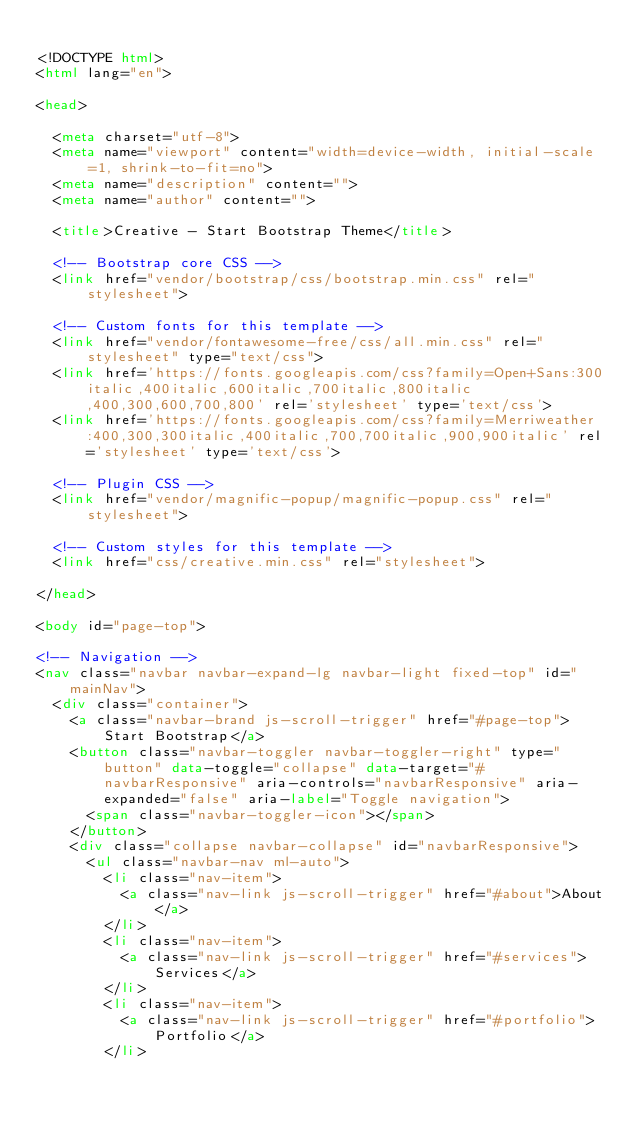<code> <loc_0><loc_0><loc_500><loc_500><_HTML_>
<!DOCTYPE html>
<html lang="en">

<head>

  <meta charset="utf-8">
  <meta name="viewport" content="width=device-width, initial-scale=1, shrink-to-fit=no">
  <meta name="description" content="">
  <meta name="author" content="">

  <title>Creative - Start Bootstrap Theme</title>

  <!-- Bootstrap core CSS -->
  <link href="vendor/bootstrap/css/bootstrap.min.css" rel="stylesheet">

  <!-- Custom fonts for this template -->
  <link href="vendor/fontawesome-free/css/all.min.css" rel="stylesheet" type="text/css">
  <link href='https://fonts.googleapis.com/css?family=Open+Sans:300italic,400italic,600italic,700italic,800italic,400,300,600,700,800' rel='stylesheet' type='text/css'>
  <link href='https://fonts.googleapis.com/css?family=Merriweather:400,300,300italic,400italic,700,700italic,900,900italic' rel='stylesheet' type='text/css'>

  <!-- Plugin CSS -->
  <link href="vendor/magnific-popup/magnific-popup.css" rel="stylesheet">

  <!-- Custom styles for this template -->
  <link href="css/creative.min.css" rel="stylesheet">

</head>

<body id="page-top">

<!-- Navigation -->
<nav class="navbar navbar-expand-lg navbar-light fixed-top" id="mainNav">
  <div class="container">
    <a class="navbar-brand js-scroll-trigger" href="#page-top">Start Bootstrap</a>
    <button class="navbar-toggler navbar-toggler-right" type="button" data-toggle="collapse" data-target="#navbarResponsive" aria-controls="navbarResponsive" aria-expanded="false" aria-label="Toggle navigation">
      <span class="navbar-toggler-icon"></span>
    </button>
    <div class="collapse navbar-collapse" id="navbarResponsive">
      <ul class="navbar-nav ml-auto">
        <li class="nav-item">
          <a class="nav-link js-scroll-trigger" href="#about">About</a>
        </li>
        <li class="nav-item">
          <a class="nav-link js-scroll-trigger" href="#services">Services</a>
        </li>
        <li class="nav-item">
          <a class="nav-link js-scroll-trigger" href="#portfolio">Portfolio</a>
        </li></code> 